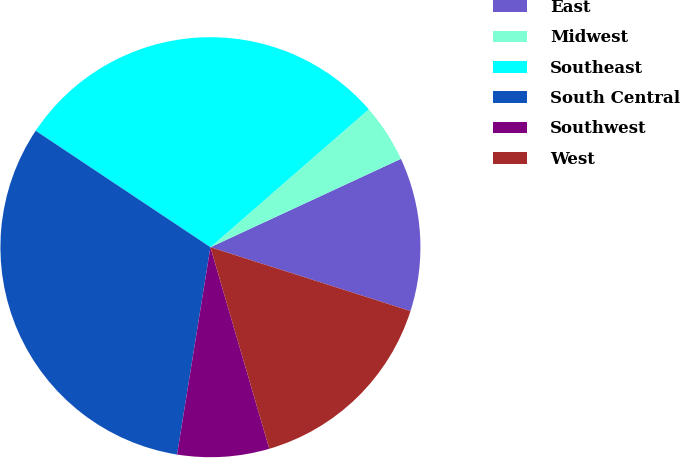<chart> <loc_0><loc_0><loc_500><loc_500><pie_chart><fcel>East<fcel>Midwest<fcel>Southeast<fcel>South Central<fcel>Southwest<fcel>West<nl><fcel>11.83%<fcel>4.49%<fcel>29.24%<fcel>31.82%<fcel>7.06%<fcel>15.56%<nl></chart> 